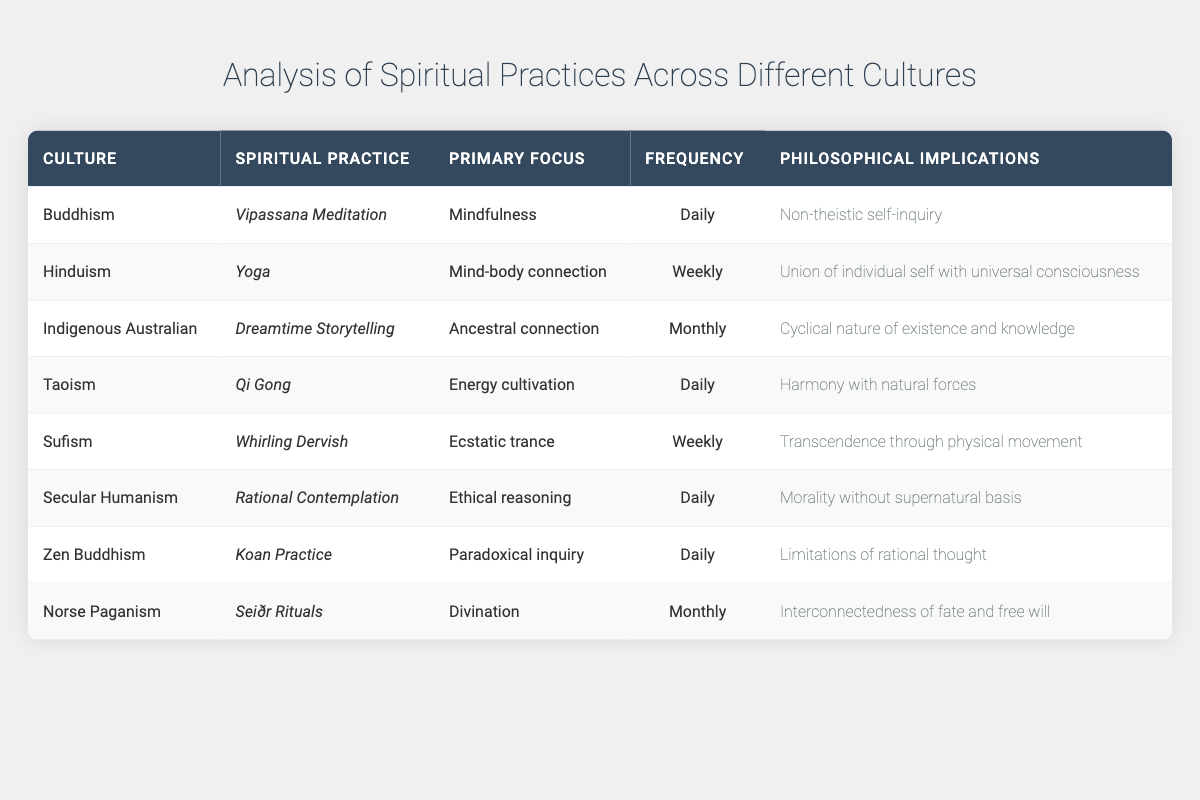What is the primary focus of Vipassana Meditation? The table indicates that the primary focus of Vipassana Meditation under Buddhism is "Mindfulness." This information is found directly in the row corresponding to Buddhism and Vipassana Meditation.
Answer: Mindfulness How often is Yoga practiced in Hinduism? According to the table, Yoga in Hinduism is practiced on a "Weekly" basis. This frequency is explicitly stated in the same row as Yoga under the Hinduism culture.
Answer: Weekly Is there a spiritual practice associated with Norse Paganism? Yes, the table shows that Norse Paganism has a spiritual practice called "Seiðr Rituals," confirming that a spiritual practice is indeed present in this culture.
Answer: Yes Which spiritual practice focuses on ancestral connection and how often is it practiced? The table shows that "Dreamtime Storytelling" in Indigenous Australian culture focuses on "Ancestral connection" and is practiced "Monthly." To answer this question, we reference the row corresponding to Indigenous Australian culture and check both the focus and frequency columns.
Answer: Dreamtime Storytelling; Monthly How many spiritual practices are practiced daily? By reviewing the table, we see that the practices "Vipassana Meditation," "Qi Gong," "Rational Contemplation," and "Koan Practice" are all practiced daily. Counting these gives us a total of four daily practices. Thus, we can determine that the total number of daily spiritual practices is 4.
Answer: 4 What is the philosophical implication of Qi Gong in Taoism? The table indicates that the philosophical implication of Qi Gong under Taoism is "Harmony with natural forces." This is a direct reference from the row dedicated to Taoism and its respective practice, Qi Gong.
Answer: Harmony with natural forces Which spiritual practice has a focus on ethical reasoning and how frequently is it engaged? "Rational Contemplation," associated with Secular Humanism, focuses on "Ethical reasoning" and is practiced "Daily." The answer is obtained by checking the respective row for Secular Humanism.
Answer: Rational Contemplation; Daily Which spiritual practices are associated with the concept of transcendence? The spiritual practices that relate to transcendence, as indicated in the table, are "Whirling Dervish" from Sufism with the implication of "Transcendence through physical movement." No other practices aim for transcendence based on the data provided.
Answer: Whirling Dervish How does the frequency of spiritual practices compare across cultures? Analyzing the frequencies from the table, we categorize them as Daily (4 practices), Weekly (2 practices), and Monthly (3 practices). With 4 daily, 2 weekly, and 3 monthly practices, we can summarize that daily practices are the most prevalent among these cultures. This indicates a strong emphasis on regular engagement in certain spiritual activities across various cultures.
Answer: Daily practices are the most prevalent 